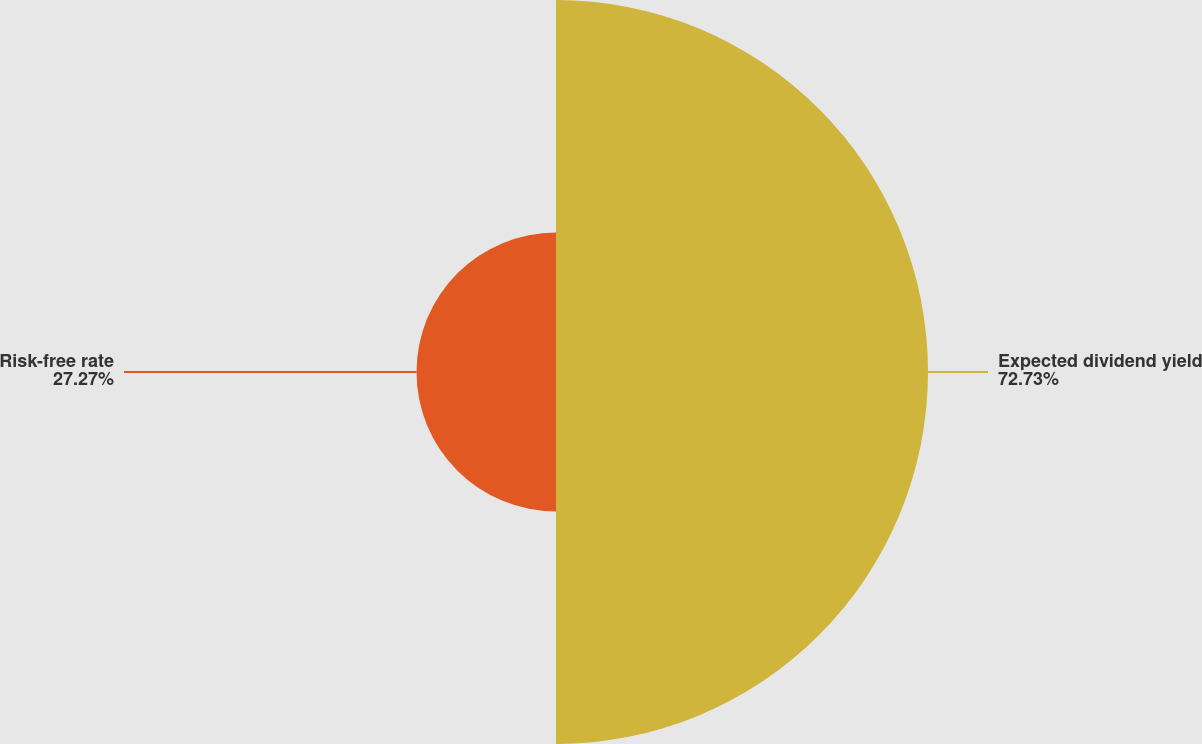<chart> <loc_0><loc_0><loc_500><loc_500><pie_chart><fcel>Expected dividend yield<fcel>Risk-free rate<nl><fcel>72.73%<fcel>27.27%<nl></chart> 